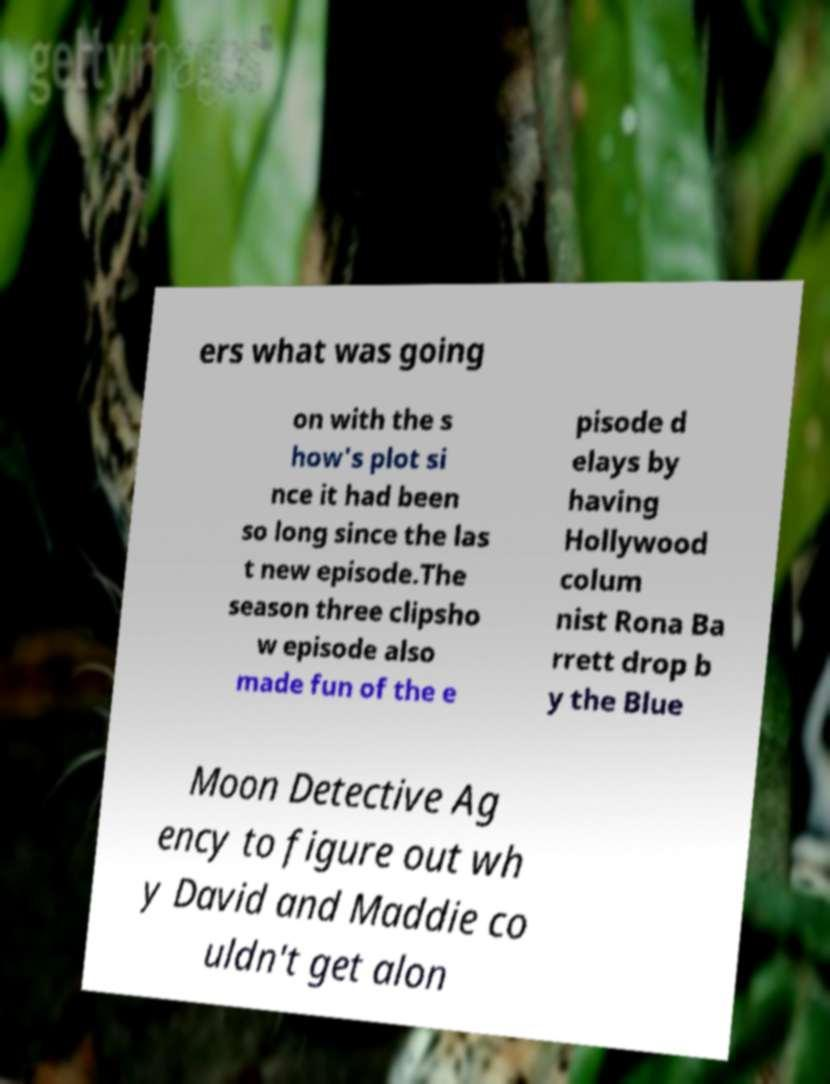Could you assist in decoding the text presented in this image and type it out clearly? ers what was going on with the s how's plot si nce it had been so long since the las t new episode.The season three clipsho w episode also made fun of the e pisode d elays by having Hollywood colum nist Rona Ba rrett drop b y the Blue Moon Detective Ag ency to figure out wh y David and Maddie co uldn't get alon 